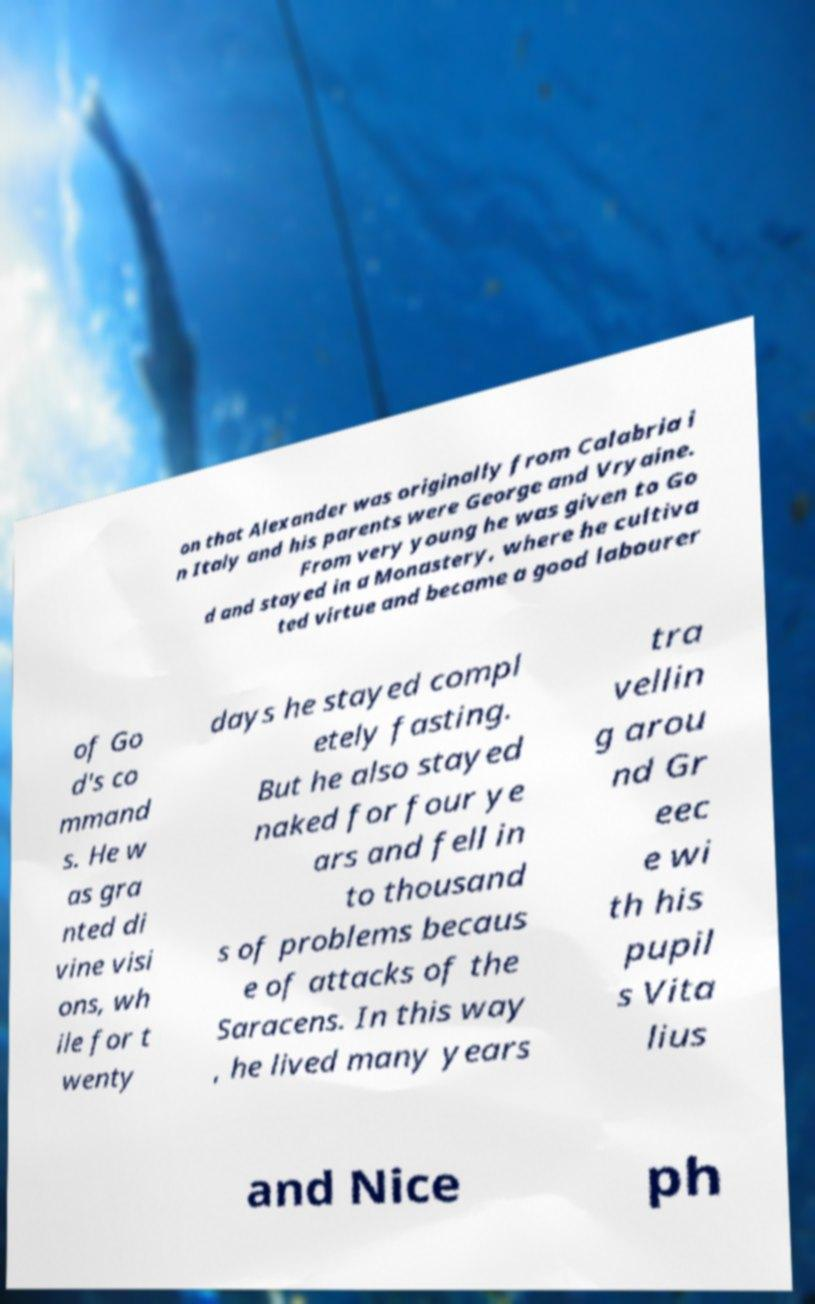There's text embedded in this image that I need extracted. Can you transcribe it verbatim? on that Alexander was originally from Calabria i n Italy and his parents were George and Vryaine. From very young he was given to Go d and stayed in a Monastery, where he cultiva ted virtue and became a good labourer of Go d's co mmand s. He w as gra nted di vine visi ons, wh ile for t wenty days he stayed compl etely fasting. But he also stayed naked for four ye ars and fell in to thousand s of problems becaus e of attacks of the Saracens. In this way , he lived many years tra vellin g arou nd Gr eec e wi th his pupil s Vita lius and Nice ph 